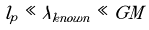<formula> <loc_0><loc_0><loc_500><loc_500>l _ { p } \ll \lambda _ { k n o w n } \ll G M</formula> 